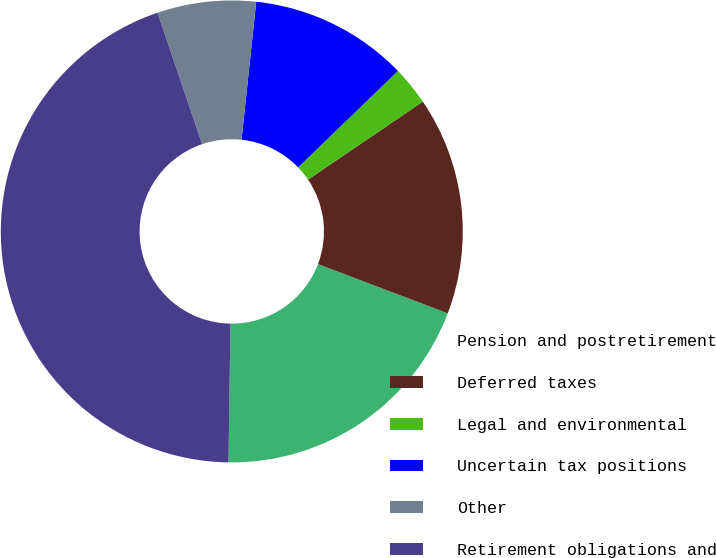Convert chart. <chart><loc_0><loc_0><loc_500><loc_500><pie_chart><fcel>Pension and postretirement<fcel>Deferred taxes<fcel>Legal and environmental<fcel>Uncertain tax positions<fcel>Other<fcel>Retirement obligations and<nl><fcel>19.46%<fcel>15.27%<fcel>2.72%<fcel>11.09%<fcel>6.9%<fcel>44.56%<nl></chart> 